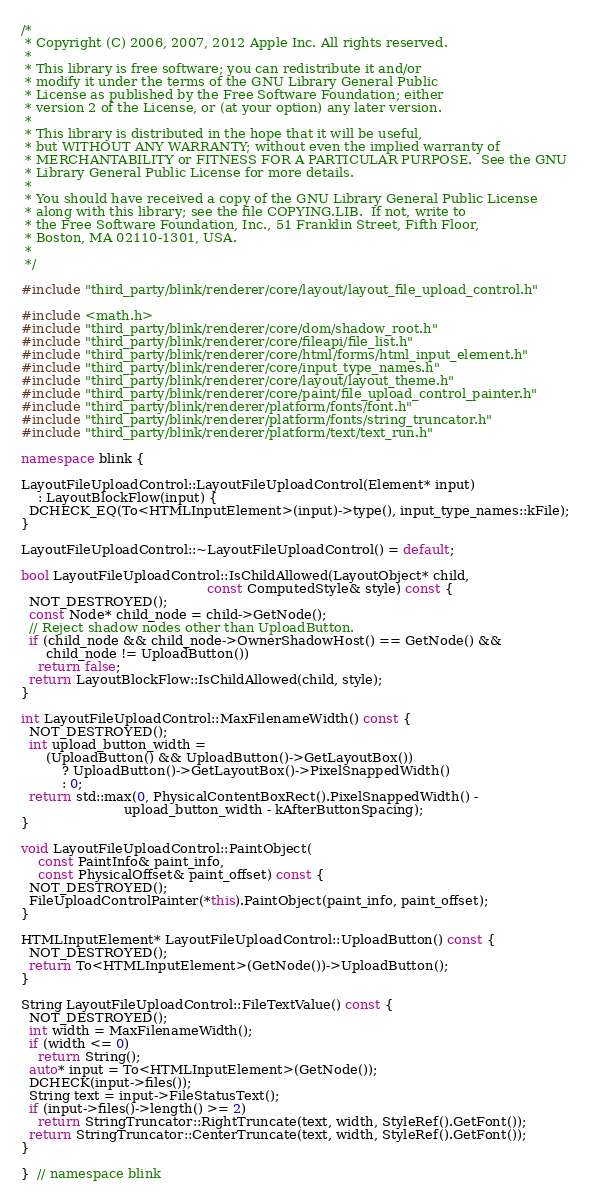<code> <loc_0><loc_0><loc_500><loc_500><_C++_>/*
 * Copyright (C) 2006, 2007, 2012 Apple Inc. All rights reserved.
 *
 * This library is free software; you can redistribute it and/or
 * modify it under the terms of the GNU Library General Public
 * License as published by the Free Software Foundation; either
 * version 2 of the License, or (at your option) any later version.
 *
 * This library is distributed in the hope that it will be useful,
 * but WITHOUT ANY WARRANTY; without even the implied warranty of
 * MERCHANTABILITY or FITNESS FOR A PARTICULAR PURPOSE.  See the GNU
 * Library General Public License for more details.
 *
 * You should have received a copy of the GNU Library General Public License
 * along with this library; see the file COPYING.LIB.  If not, write to
 * the Free Software Foundation, Inc., 51 Franklin Street, Fifth Floor,
 * Boston, MA 02110-1301, USA.
 *
 */

#include "third_party/blink/renderer/core/layout/layout_file_upload_control.h"

#include <math.h>
#include "third_party/blink/renderer/core/dom/shadow_root.h"
#include "third_party/blink/renderer/core/fileapi/file_list.h"
#include "third_party/blink/renderer/core/html/forms/html_input_element.h"
#include "third_party/blink/renderer/core/input_type_names.h"
#include "third_party/blink/renderer/core/layout/layout_theme.h"
#include "third_party/blink/renderer/core/paint/file_upload_control_painter.h"
#include "third_party/blink/renderer/platform/fonts/font.h"
#include "third_party/blink/renderer/platform/fonts/string_truncator.h"
#include "third_party/blink/renderer/platform/text/text_run.h"

namespace blink {

LayoutFileUploadControl::LayoutFileUploadControl(Element* input)
    : LayoutBlockFlow(input) {
  DCHECK_EQ(To<HTMLInputElement>(input)->type(), input_type_names::kFile);
}

LayoutFileUploadControl::~LayoutFileUploadControl() = default;

bool LayoutFileUploadControl::IsChildAllowed(LayoutObject* child,
                                             const ComputedStyle& style) const {
  NOT_DESTROYED();
  const Node* child_node = child->GetNode();
  // Reject shadow nodes other than UploadButton.
  if (child_node && child_node->OwnerShadowHost() == GetNode() &&
      child_node != UploadButton())
    return false;
  return LayoutBlockFlow::IsChildAllowed(child, style);
}

int LayoutFileUploadControl::MaxFilenameWidth() const {
  NOT_DESTROYED();
  int upload_button_width =
      (UploadButton() && UploadButton()->GetLayoutBox())
          ? UploadButton()->GetLayoutBox()->PixelSnappedWidth()
          : 0;
  return std::max(0, PhysicalContentBoxRect().PixelSnappedWidth() -
                         upload_button_width - kAfterButtonSpacing);
}

void LayoutFileUploadControl::PaintObject(
    const PaintInfo& paint_info,
    const PhysicalOffset& paint_offset) const {
  NOT_DESTROYED();
  FileUploadControlPainter(*this).PaintObject(paint_info, paint_offset);
}

HTMLInputElement* LayoutFileUploadControl::UploadButton() const {
  NOT_DESTROYED();
  return To<HTMLInputElement>(GetNode())->UploadButton();
}

String LayoutFileUploadControl::FileTextValue() const {
  NOT_DESTROYED();
  int width = MaxFilenameWidth();
  if (width <= 0)
    return String();
  auto* input = To<HTMLInputElement>(GetNode());
  DCHECK(input->files());
  String text = input->FileStatusText();
  if (input->files()->length() >= 2)
    return StringTruncator::RightTruncate(text, width, StyleRef().GetFont());
  return StringTruncator::CenterTruncate(text, width, StyleRef().GetFont());
}

}  // namespace blink
</code> 